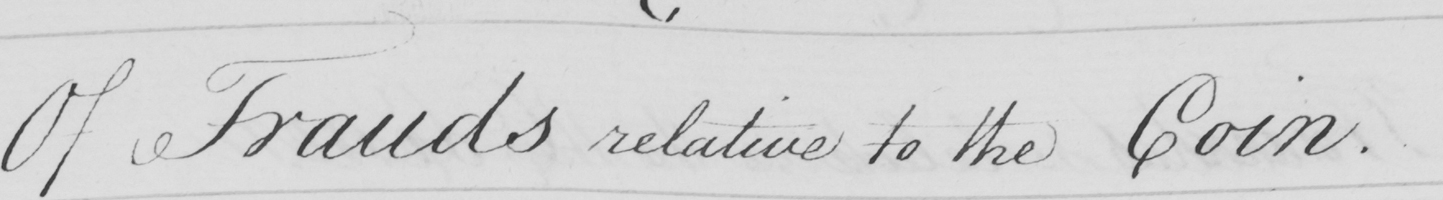Please transcribe the handwritten text in this image. Of Frauds relative to the Coin . 